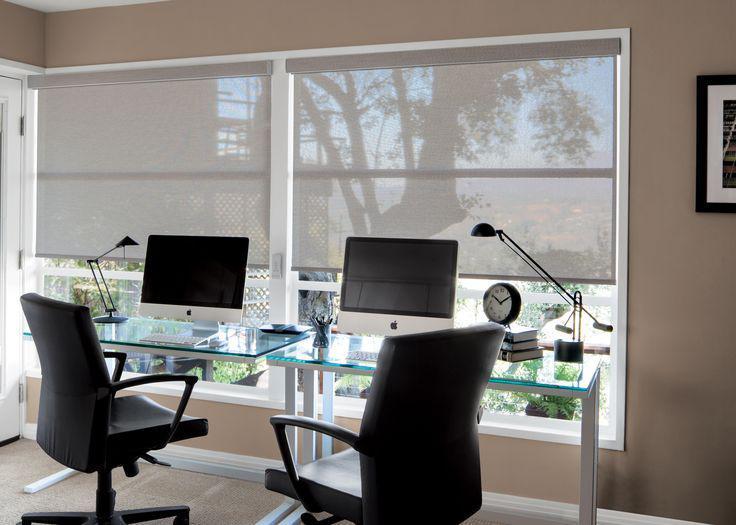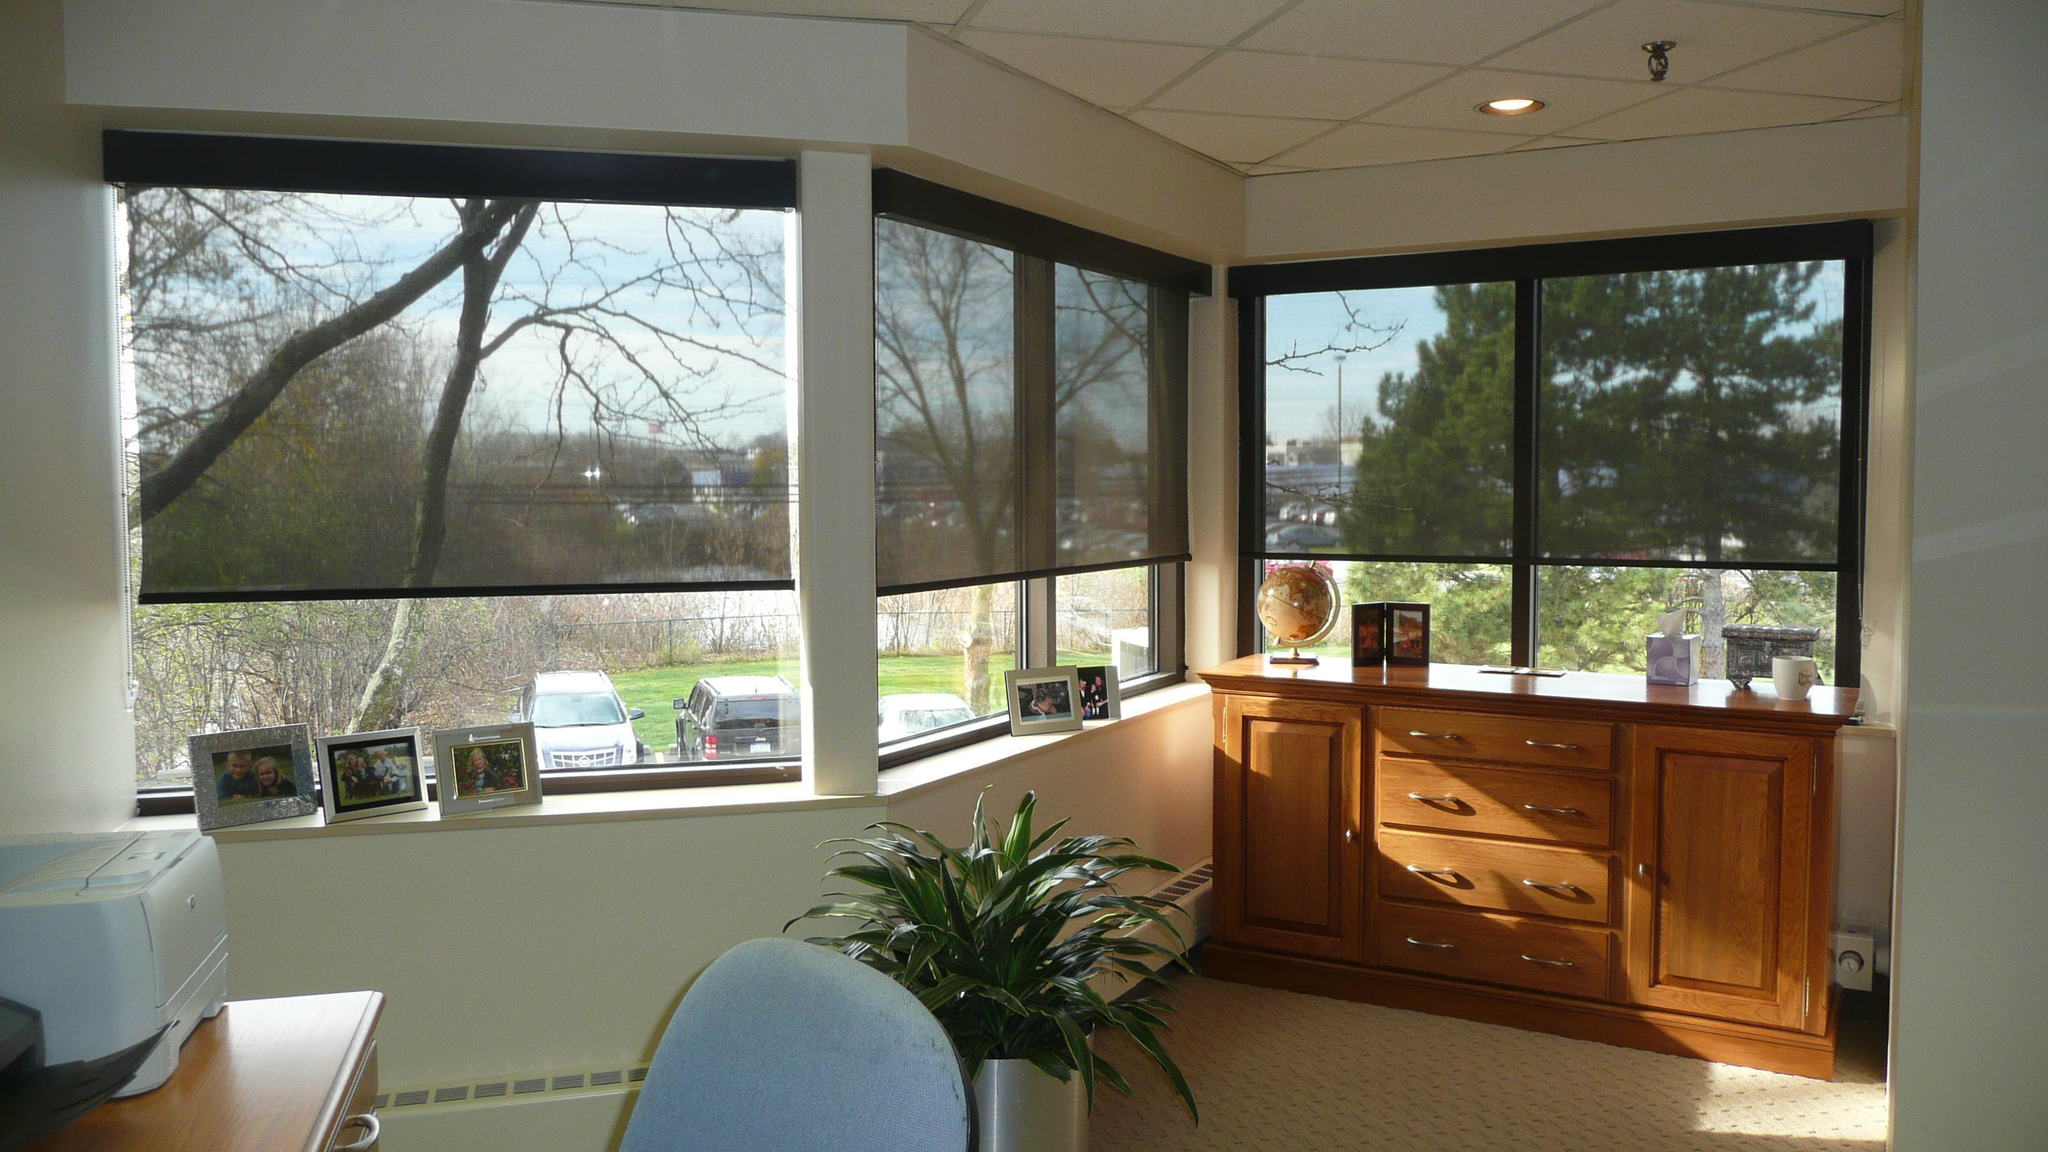The first image is the image on the left, the second image is the image on the right. For the images shown, is this caption "One image contains computers at desks, like in an office, and the other does not." true? Answer yes or no. Yes. 